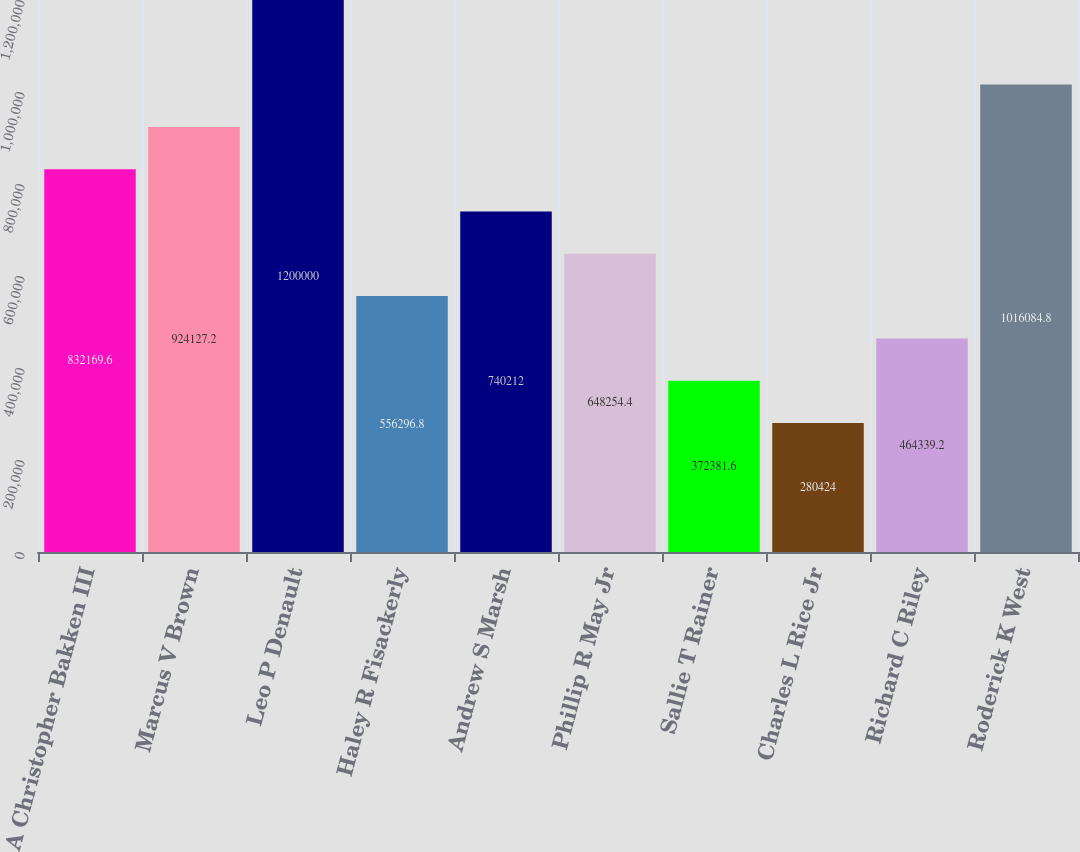Convert chart to OTSL. <chart><loc_0><loc_0><loc_500><loc_500><bar_chart><fcel>A Christopher Bakken III<fcel>Marcus V Brown<fcel>Leo P Denault<fcel>Haley R Fisackerly<fcel>Andrew S Marsh<fcel>Phillip R May Jr<fcel>Sallie T Rainer<fcel>Charles L Rice Jr<fcel>Richard C Riley<fcel>Roderick K West<nl><fcel>832170<fcel>924127<fcel>1.2e+06<fcel>556297<fcel>740212<fcel>648254<fcel>372382<fcel>280424<fcel>464339<fcel>1.01608e+06<nl></chart> 